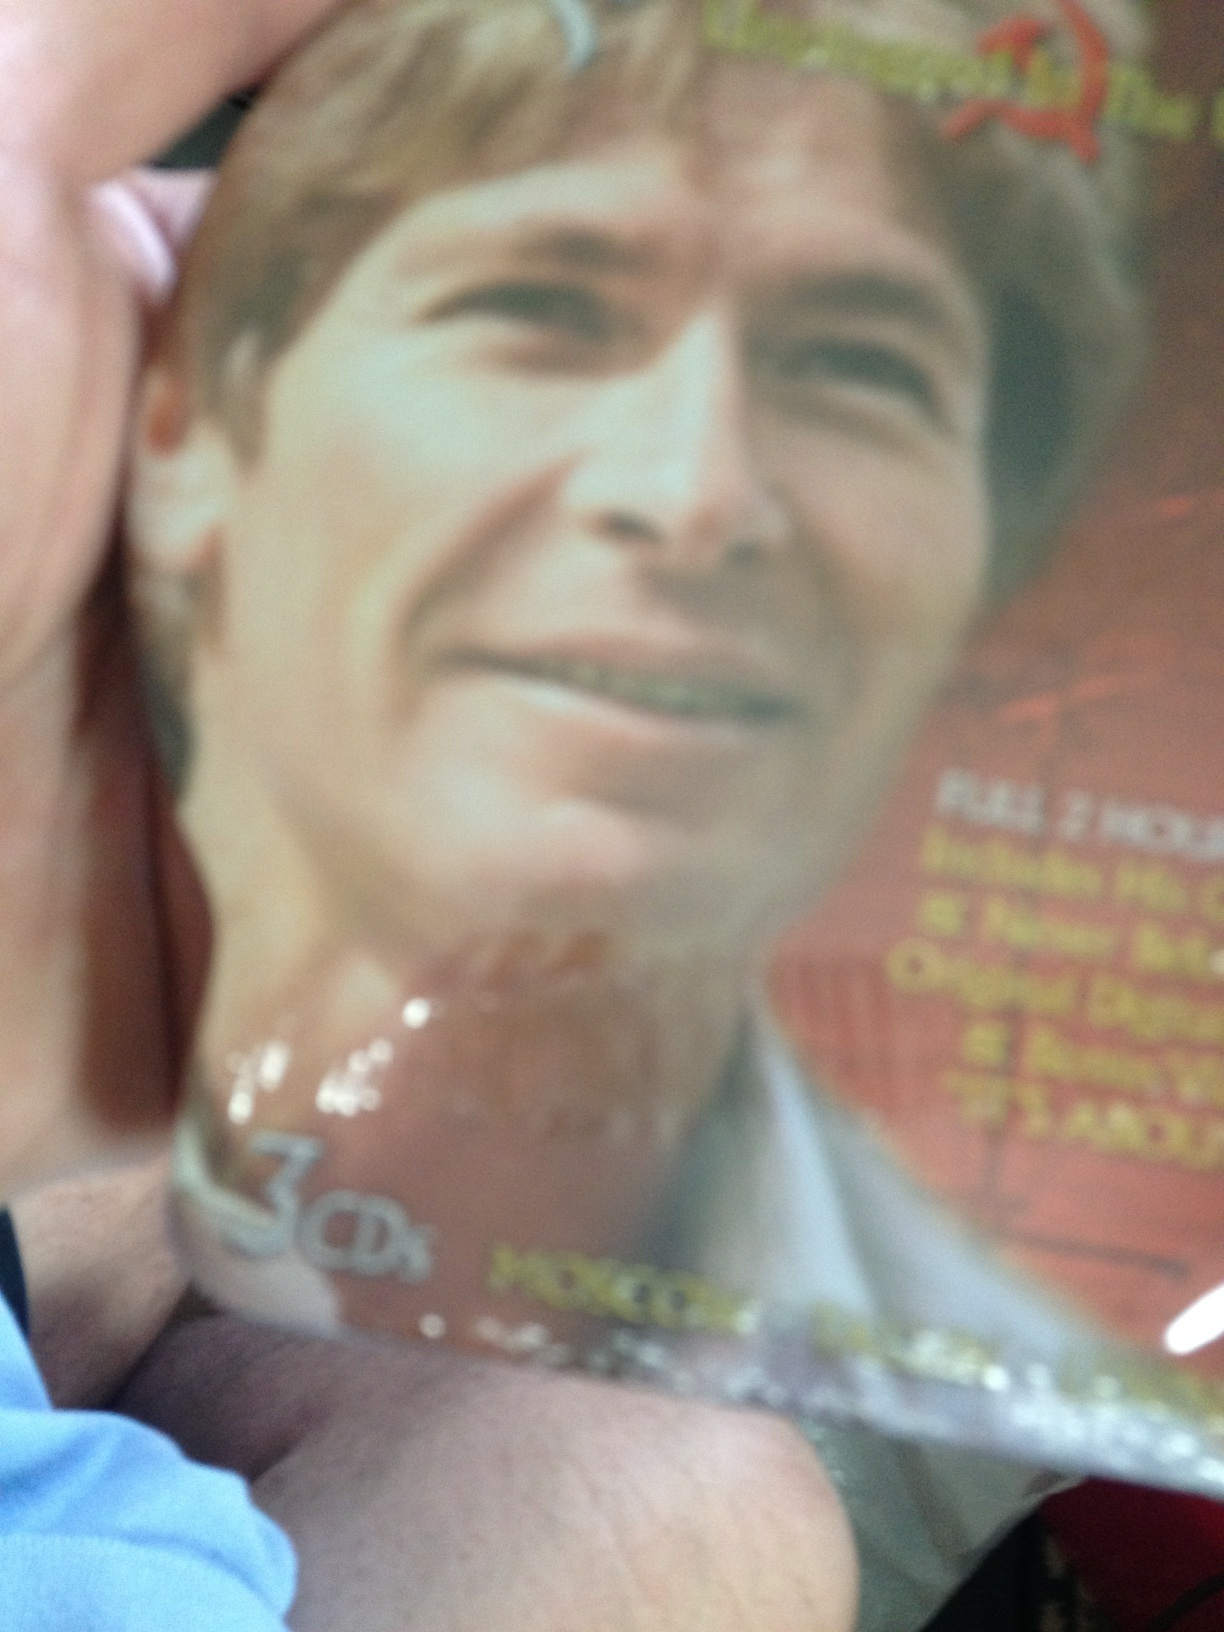Describe the artist on the cover. What might the music be about? The artist on the cover appears to be a middle-aged man with a friendly, approachable demeanor. He has a casual yet professional look, which might suggest that the music could be heartfelt, sincere, and potentially narrative-driven, focusing on personal experiences or storytelling. Imagine this CD tells a fantastical story. What could that story be? Imagine this CD encompasses the epic tale of a wanderer who sets off on an interstellar journey to discover new worlds and civilizations. Throughout his travels, he encounters mystical beings, participates in grand adventures, and learns profound truths about existence and the universe. Each song on the CD represents a different chapter of his extraordinary voyage, filled with awe, wonder, and deep introspection. 